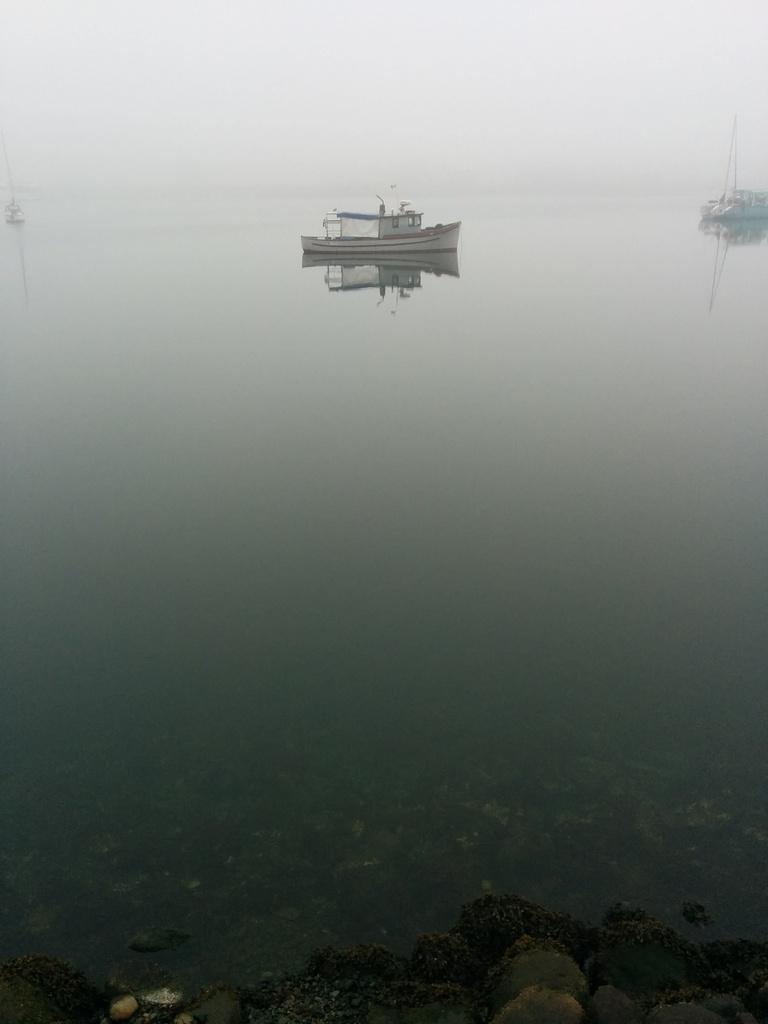How would you summarize this image in a sentence or two? Above this water there are boats. On this reflection of boats. 